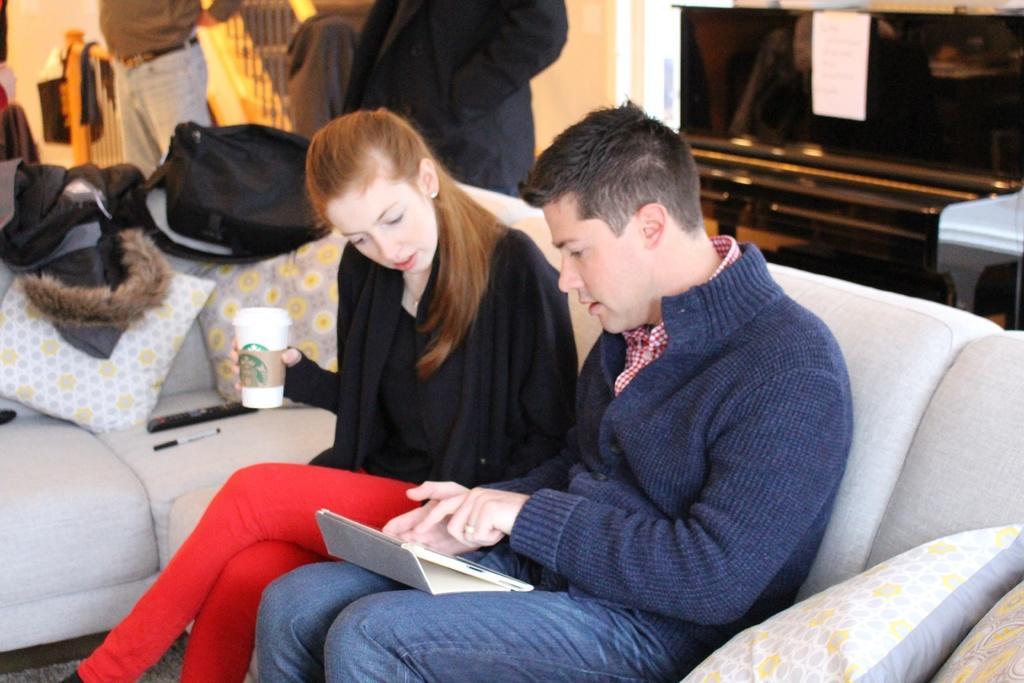How would you summarize this image in a sentence or two? In this image I can see two persons sitting on the couch. The person at right is wearing blue color dress and the person at left is wearing black and red color dress and holding a glass. Background I can see two persons standing and I can also see few stairs and few objects on the couch and the wall is in white color. 